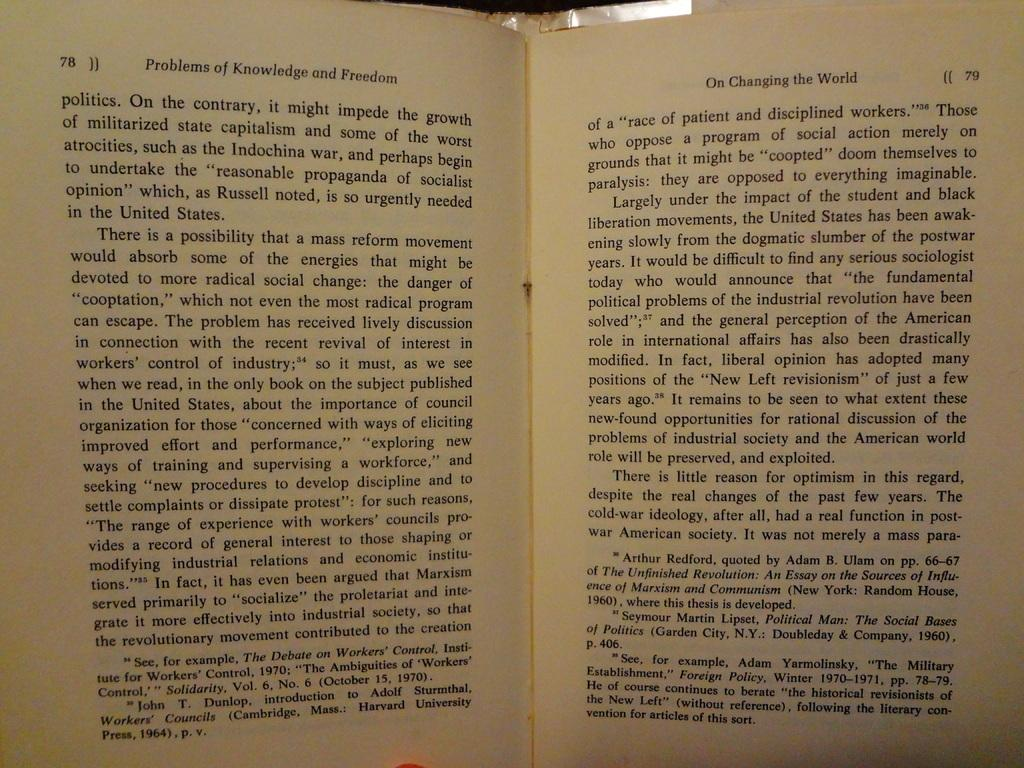Provide a one-sentence caption for the provided image. A book titled Problems of Knowledge and Freedom is open to pages 78 and 79. 